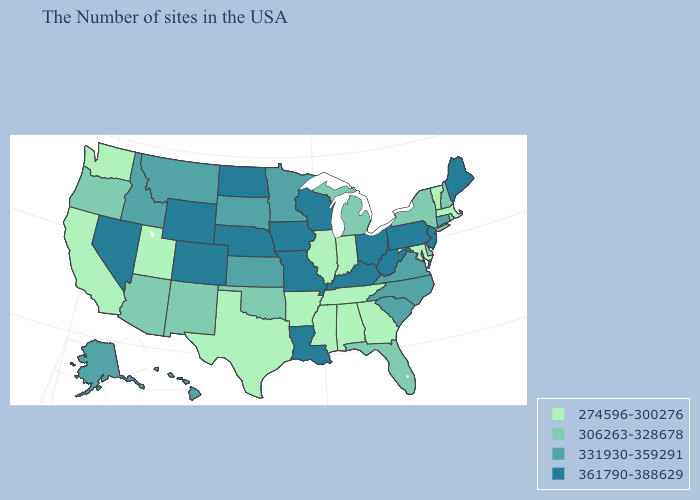Is the legend a continuous bar?
Answer briefly. No. Does Nebraska have the same value as West Virginia?
Be succinct. Yes. What is the highest value in states that border North Carolina?
Answer briefly. 331930-359291. Does Nebraska have a lower value than Wisconsin?
Be succinct. No. Name the states that have a value in the range 306263-328678?
Short answer required. Rhode Island, New Hampshire, New York, Delaware, Florida, Michigan, Oklahoma, New Mexico, Arizona, Oregon. Name the states that have a value in the range 361790-388629?
Answer briefly. Maine, New Jersey, Pennsylvania, West Virginia, Ohio, Kentucky, Wisconsin, Louisiana, Missouri, Iowa, Nebraska, North Dakota, Wyoming, Colorado, Nevada. Name the states that have a value in the range 361790-388629?
Quick response, please. Maine, New Jersey, Pennsylvania, West Virginia, Ohio, Kentucky, Wisconsin, Louisiana, Missouri, Iowa, Nebraska, North Dakota, Wyoming, Colorado, Nevada. Does Nebraska have the same value as Alabama?
Concise answer only. No. What is the value of West Virginia?
Short answer required. 361790-388629. What is the lowest value in the USA?
Short answer required. 274596-300276. Name the states that have a value in the range 274596-300276?
Keep it brief. Massachusetts, Vermont, Maryland, Georgia, Indiana, Alabama, Tennessee, Illinois, Mississippi, Arkansas, Texas, Utah, California, Washington. What is the value of Iowa?
Answer briefly. 361790-388629. Does Arizona have the same value as New Hampshire?
Quick response, please. Yes. Name the states that have a value in the range 306263-328678?
Write a very short answer. Rhode Island, New Hampshire, New York, Delaware, Florida, Michigan, Oklahoma, New Mexico, Arizona, Oregon. Which states hav the highest value in the Northeast?
Answer briefly. Maine, New Jersey, Pennsylvania. 